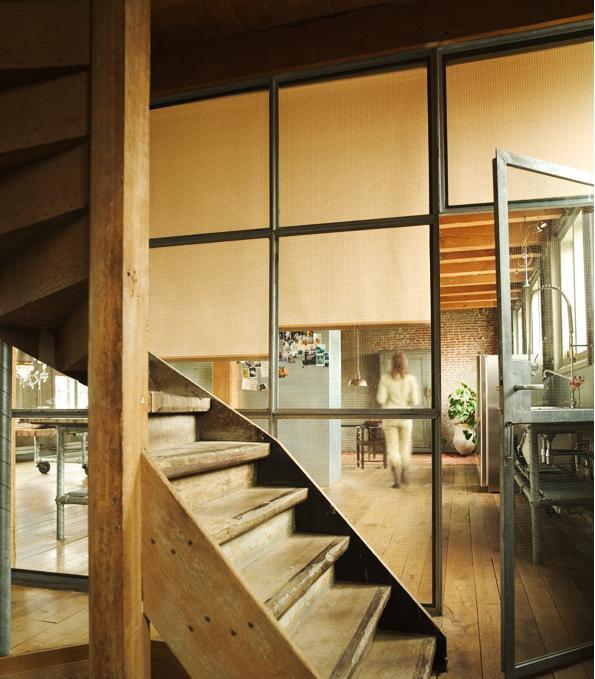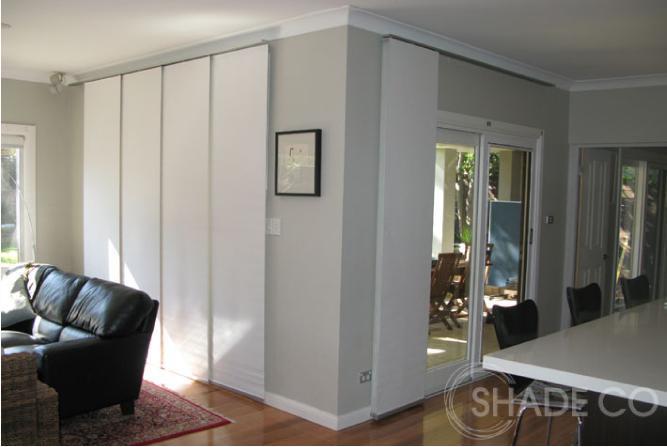The first image is the image on the left, the second image is the image on the right. Considering the images on both sides, is "The left and right image contains a total of five windows raised off the floor." valid? Answer yes or no. No. The first image is the image on the left, the second image is the image on the right. Analyze the images presented: Is the assertion "An image with a tall lamp at the right includes at least three beige window shades with the upper part of the windows uncovered." valid? Answer yes or no. No. 